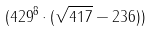<formula> <loc_0><loc_0><loc_500><loc_500>( 4 2 9 ^ { 8 } \cdot ( \sqrt { 4 1 7 } - 2 3 6 ) )</formula> 